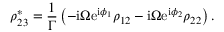Convert formula to latex. <formula><loc_0><loc_0><loc_500><loc_500>\rho _ { 2 3 } ^ { * } = \frac { 1 } { \Gamma } \left ( - i \Omega e ^ { i \phi _ { 1 } } \rho _ { 1 2 } - i \Omega e ^ { i \phi _ { 2 } } \rho _ { 2 2 } \right ) .</formula> 